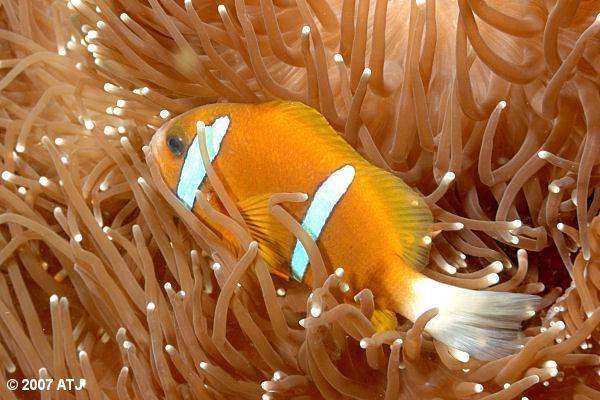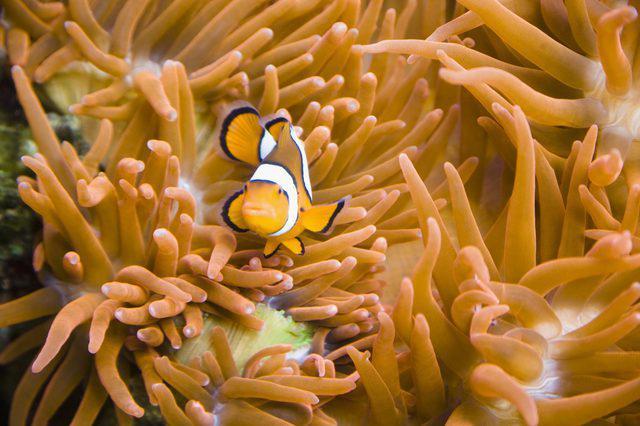The first image is the image on the left, the second image is the image on the right. Examine the images to the left and right. Is the description "In at least one image there is a single white clownfish with white, black and orange colors swimming through  the arms of corral." accurate? Answer yes or no. Yes. The first image is the image on the left, the second image is the image on the right. Given the left and right images, does the statement "Each image features no more than two orange fish in the foreground, and the fish in the left and right images are posed among anemone tendrils of the same color." hold true? Answer yes or no. Yes. 